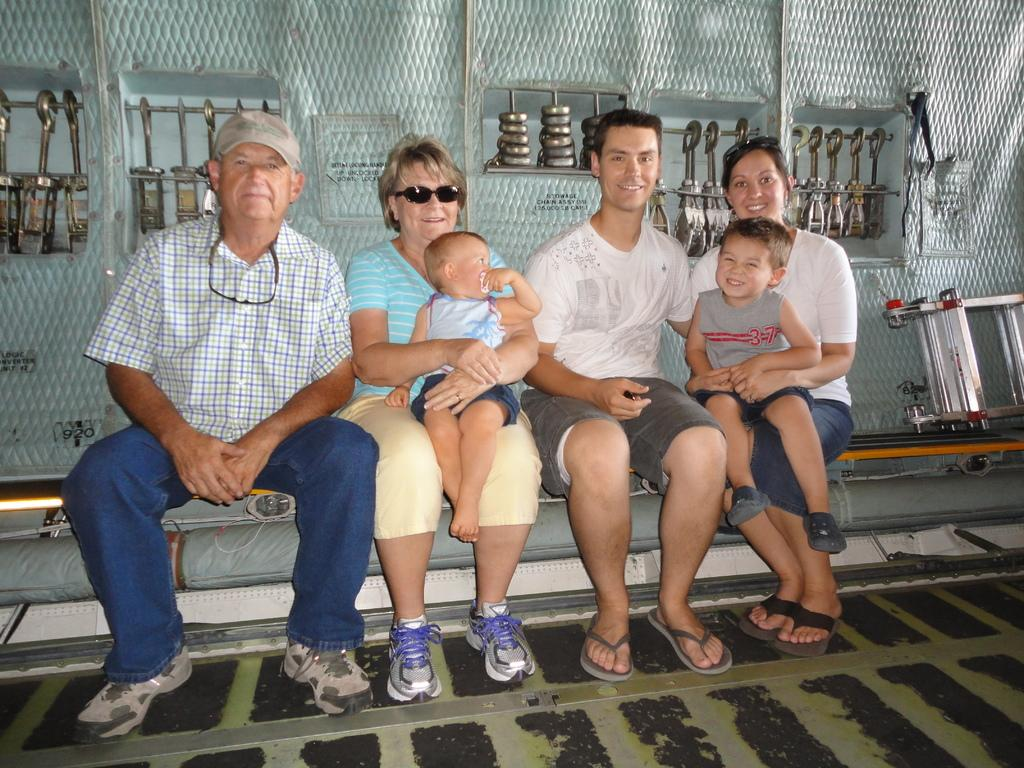What are the people in the image doing? The people in the image are sitting and posing for a photo. What can be seen in the background of the image? There are objects attached to the wall in the background. What is visible at the bottom of the image? The floor is visible at the bottom of the image. Can you describe the earthquake happening in the image? There is no earthquake present in the image. 